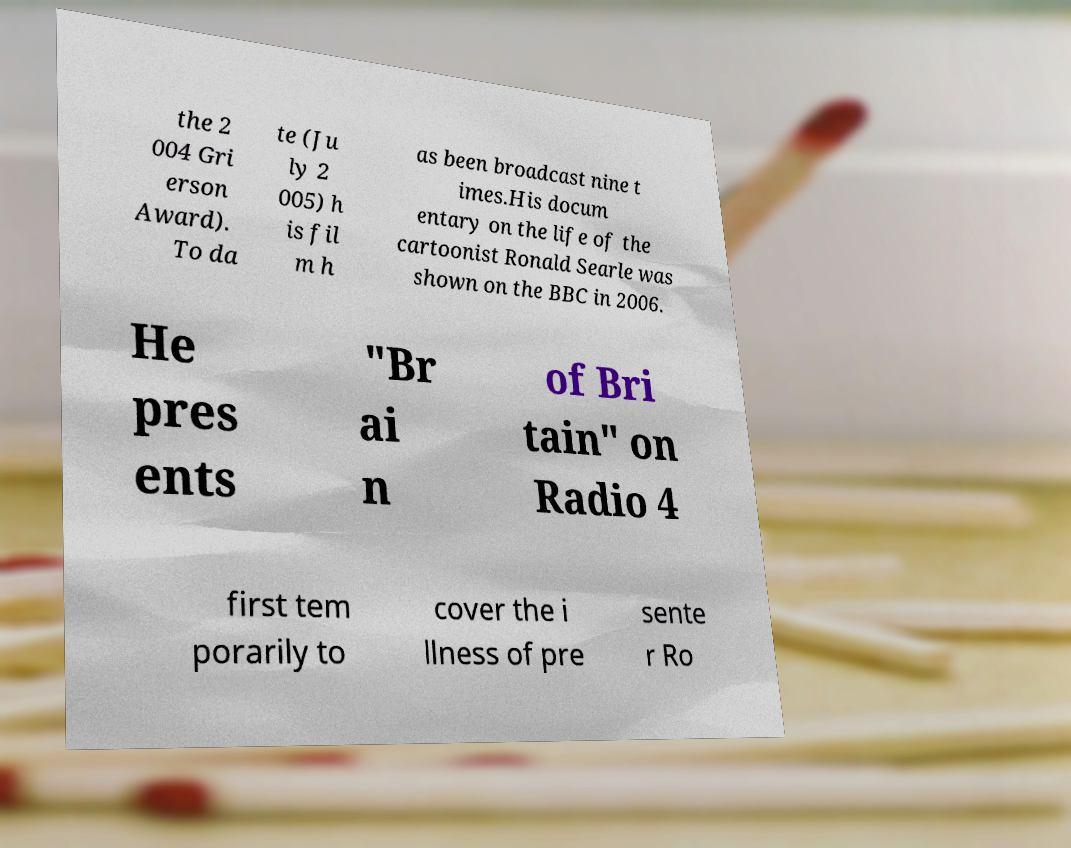Could you assist in decoding the text presented in this image and type it out clearly? the 2 004 Gri erson Award). To da te (Ju ly 2 005) h is fil m h as been broadcast nine t imes.His docum entary on the life of the cartoonist Ronald Searle was shown on the BBC in 2006. He pres ents "Br ai n of Bri tain" on Radio 4 first tem porarily to cover the i llness of pre sente r Ro 